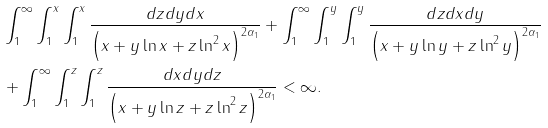<formula> <loc_0><loc_0><loc_500><loc_500>& \int _ { 1 } ^ { \infty } \int _ { 1 } ^ { x } \int _ { 1 } ^ { x } \frac { d z d y d x } { \left ( x + y \ln x + z \ln ^ { 2 } x \right ) ^ { 2 \alpha _ { 1 } } } + \int _ { 1 } ^ { \infty } \int _ { 1 } ^ { y } \int _ { 1 } ^ { y } \frac { d z d x d y } { \left ( x + y \ln y + z \ln ^ { 2 } y \right ) ^ { 2 \alpha _ { 1 } } } \\ & + \int _ { 1 } ^ { \infty } \int _ { 1 } ^ { z } \int _ { 1 } ^ { z } \frac { d x d y d z } { \left ( x + y \ln z + z \ln ^ { 2 } z \right ) ^ { 2 \alpha _ { 1 } } } < \infty .</formula> 